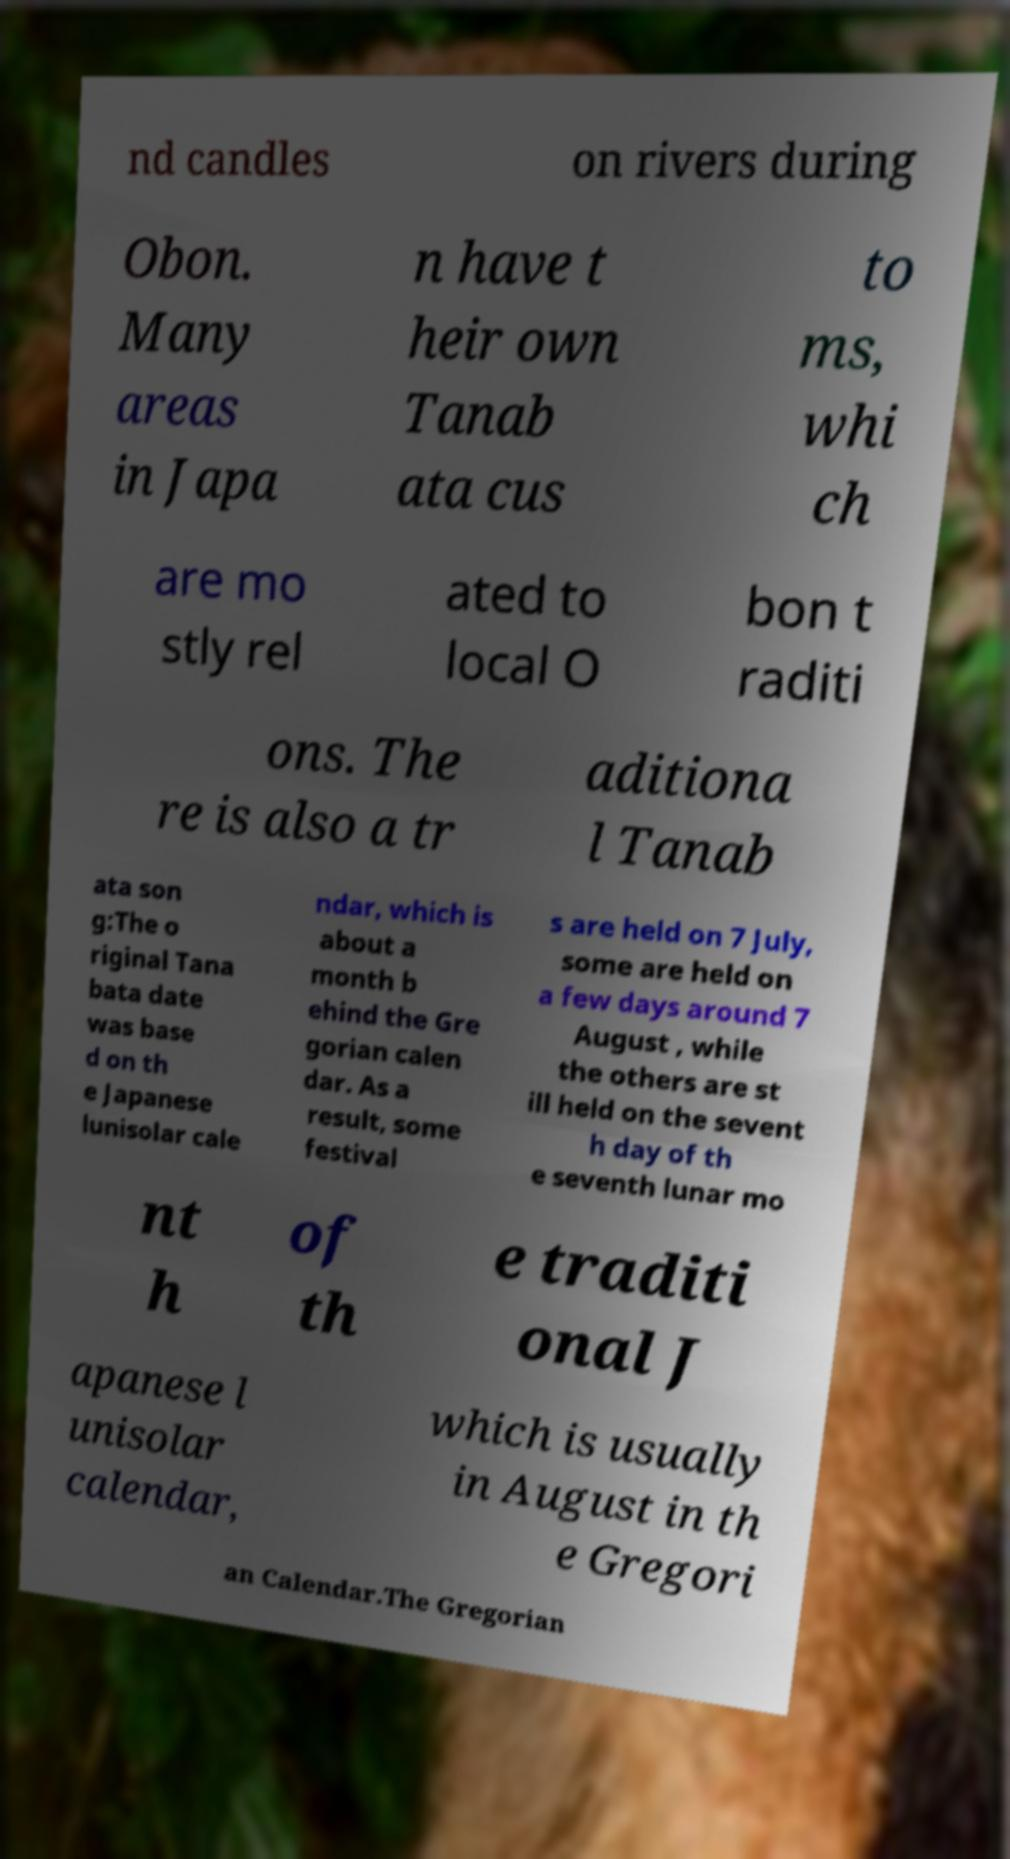Could you assist in decoding the text presented in this image and type it out clearly? nd candles on rivers during Obon. Many areas in Japa n have t heir own Tanab ata cus to ms, whi ch are mo stly rel ated to local O bon t raditi ons. The re is also a tr aditiona l Tanab ata son g:The o riginal Tana bata date was base d on th e Japanese lunisolar cale ndar, which is about a month b ehind the Gre gorian calen dar. As a result, some festival s are held on 7 July, some are held on a few days around 7 August , while the others are st ill held on the sevent h day of th e seventh lunar mo nt h of th e traditi onal J apanese l unisolar calendar, which is usually in August in th e Gregori an Calendar.The Gregorian 